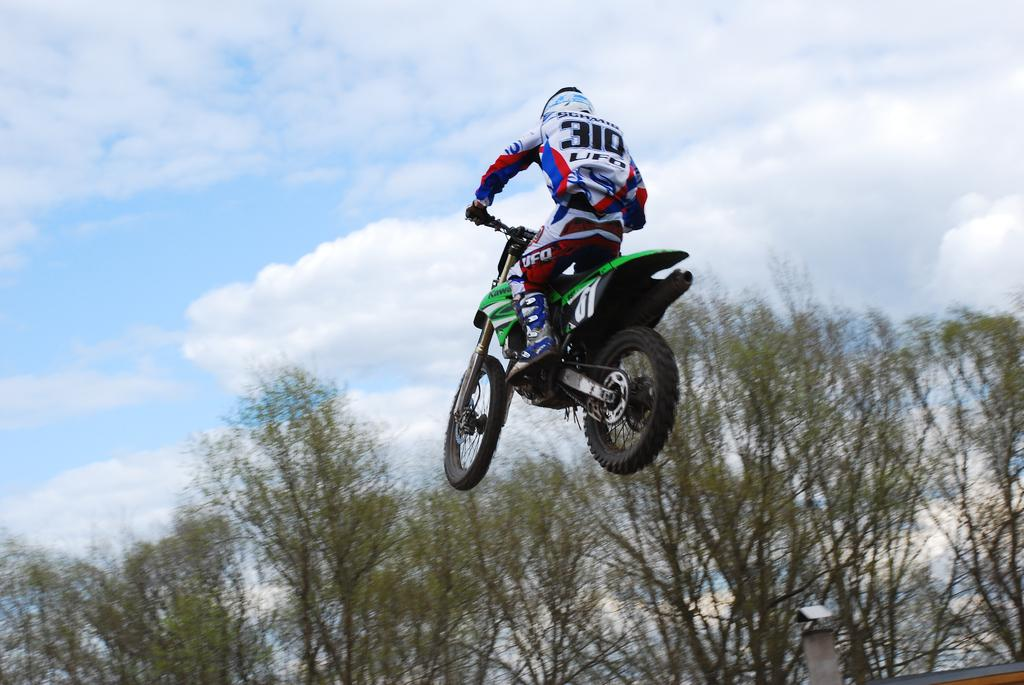What is the main subject of the image? There is a person on a motorcycle in the image. What can be seen in the background of the image? There are trees visible in the background of the image. What part of the natural environment is visible in the image? The sky is visible in the image. How many chairs are present in the image? There are no chairs visible in the image. What type of carriage can be seen in the image? There is no carriage present in the image. 